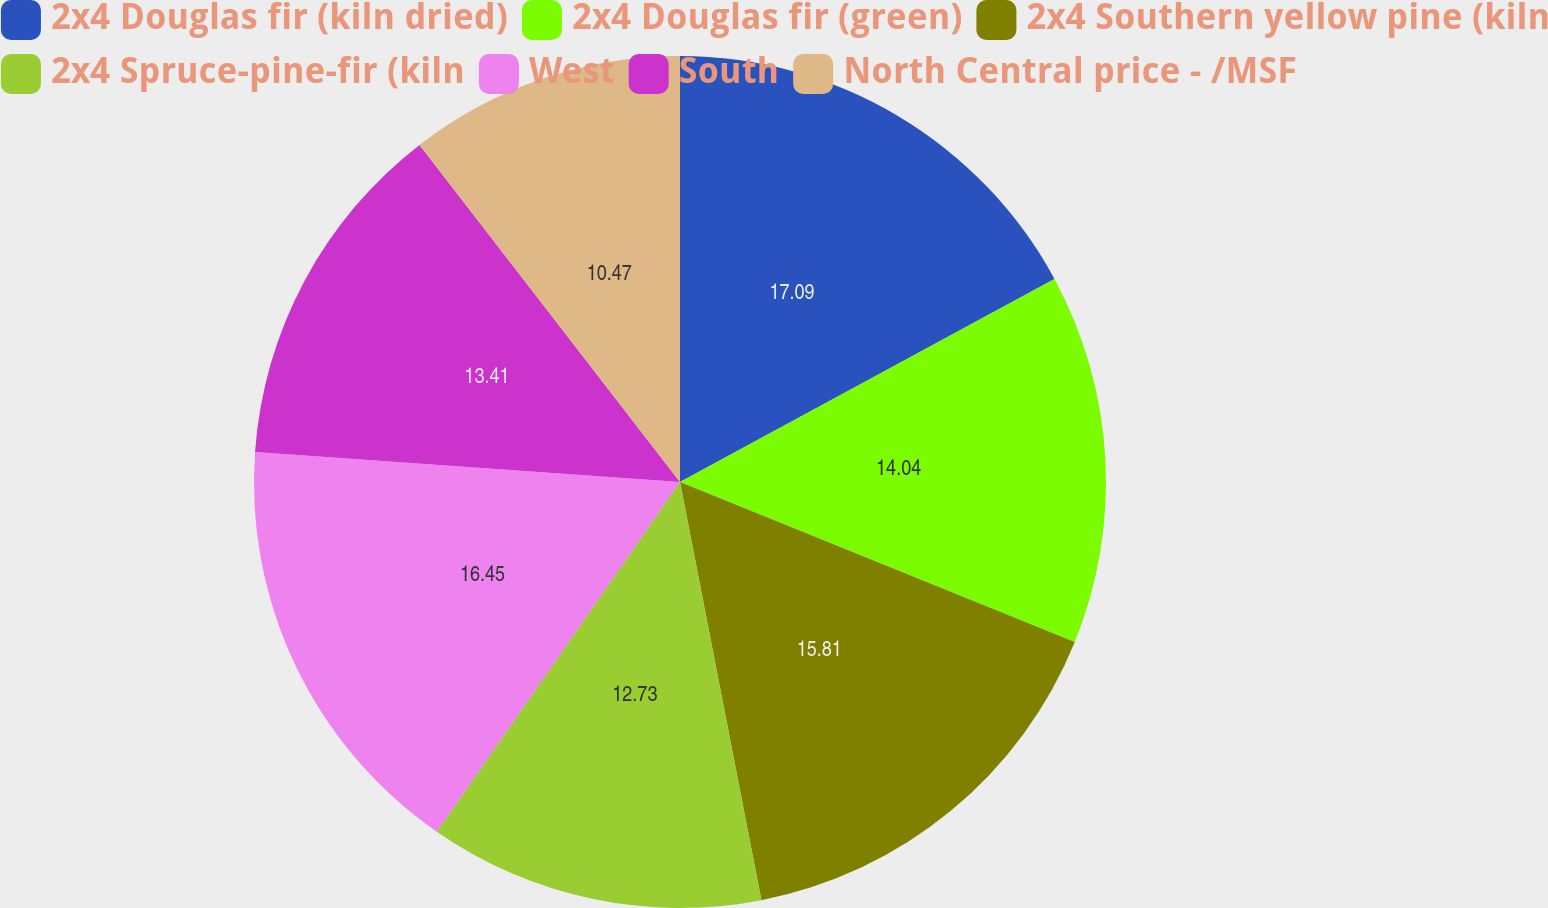<chart> <loc_0><loc_0><loc_500><loc_500><pie_chart><fcel>2x4 Douglas fir (kiln dried)<fcel>2x4 Douglas fir (green)<fcel>2x4 Southern yellow pine (kiln<fcel>2x4 Spruce-pine-fir (kiln<fcel>West<fcel>South<fcel>North Central price - /MSF<nl><fcel>17.09%<fcel>14.04%<fcel>15.81%<fcel>12.73%<fcel>16.45%<fcel>13.41%<fcel>10.47%<nl></chart> 